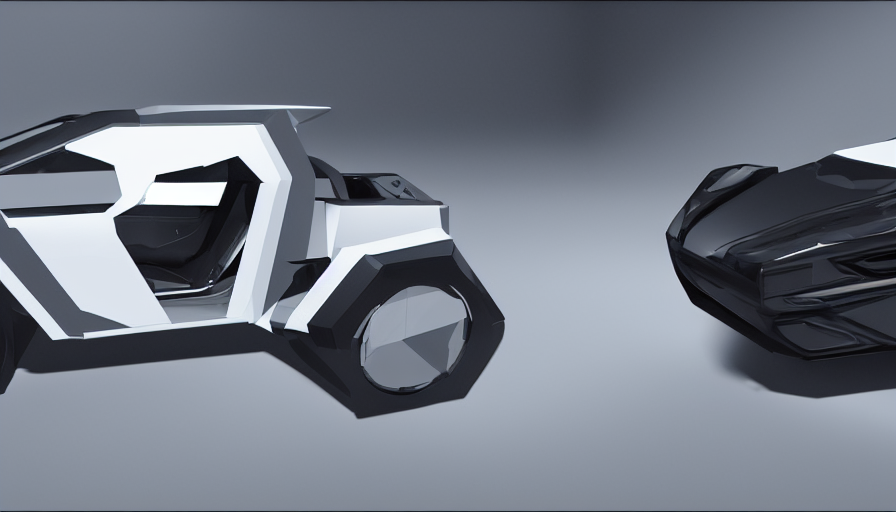What is the significance of the color choices in this image? The color choices in the image seem strategic, designed to enhance the futuristic and high-tech nature of these objects. The predominant use of blacks and whites contributes to a minimalistic aesthetic, which often signifies sophistication and cutting-edge design in technology. The absence of vibrant colors allows the viewer to focus on the shapes and design features, suggesting these objects prioritize function and form in their essence. 